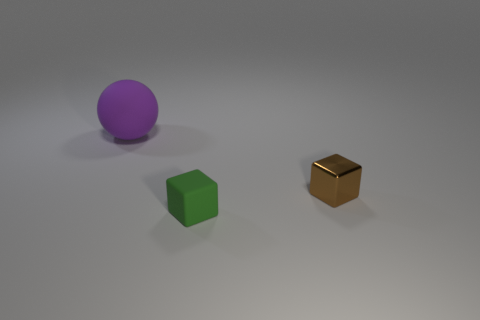Is there anything else that is the same size as the purple matte sphere?
Your answer should be very brief. No. How many other things are there of the same material as the brown thing?
Your answer should be compact. 0. Is the size of the green object the same as the block behind the green cube?
Keep it short and to the point. Yes. The tiny metal cube has what color?
Provide a succinct answer. Brown. There is a thing behind the tiny cube behind the cube that is to the left of the metal cube; what is its shape?
Your response must be concise. Sphere. There is a small object that is behind the object in front of the metallic object; what is it made of?
Ensure brevity in your answer.  Metal. There is a small green thing that is the same material as the large purple ball; what shape is it?
Ensure brevity in your answer.  Cube. Are there any other things that are the same shape as the big purple thing?
Your response must be concise. No. There is a large sphere; what number of purple things are to the right of it?
Give a very brief answer. 0. Is there a tiny red sphere?
Give a very brief answer. No. 